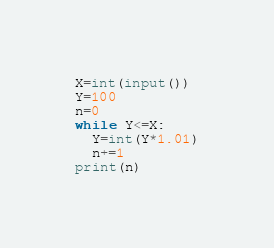Convert code to text. <code><loc_0><loc_0><loc_500><loc_500><_Python_>X=int(input())
Y=100
n=0
while Y<=X:
  Y=int(Y*1.01)
  n+=1
print(n)</code> 